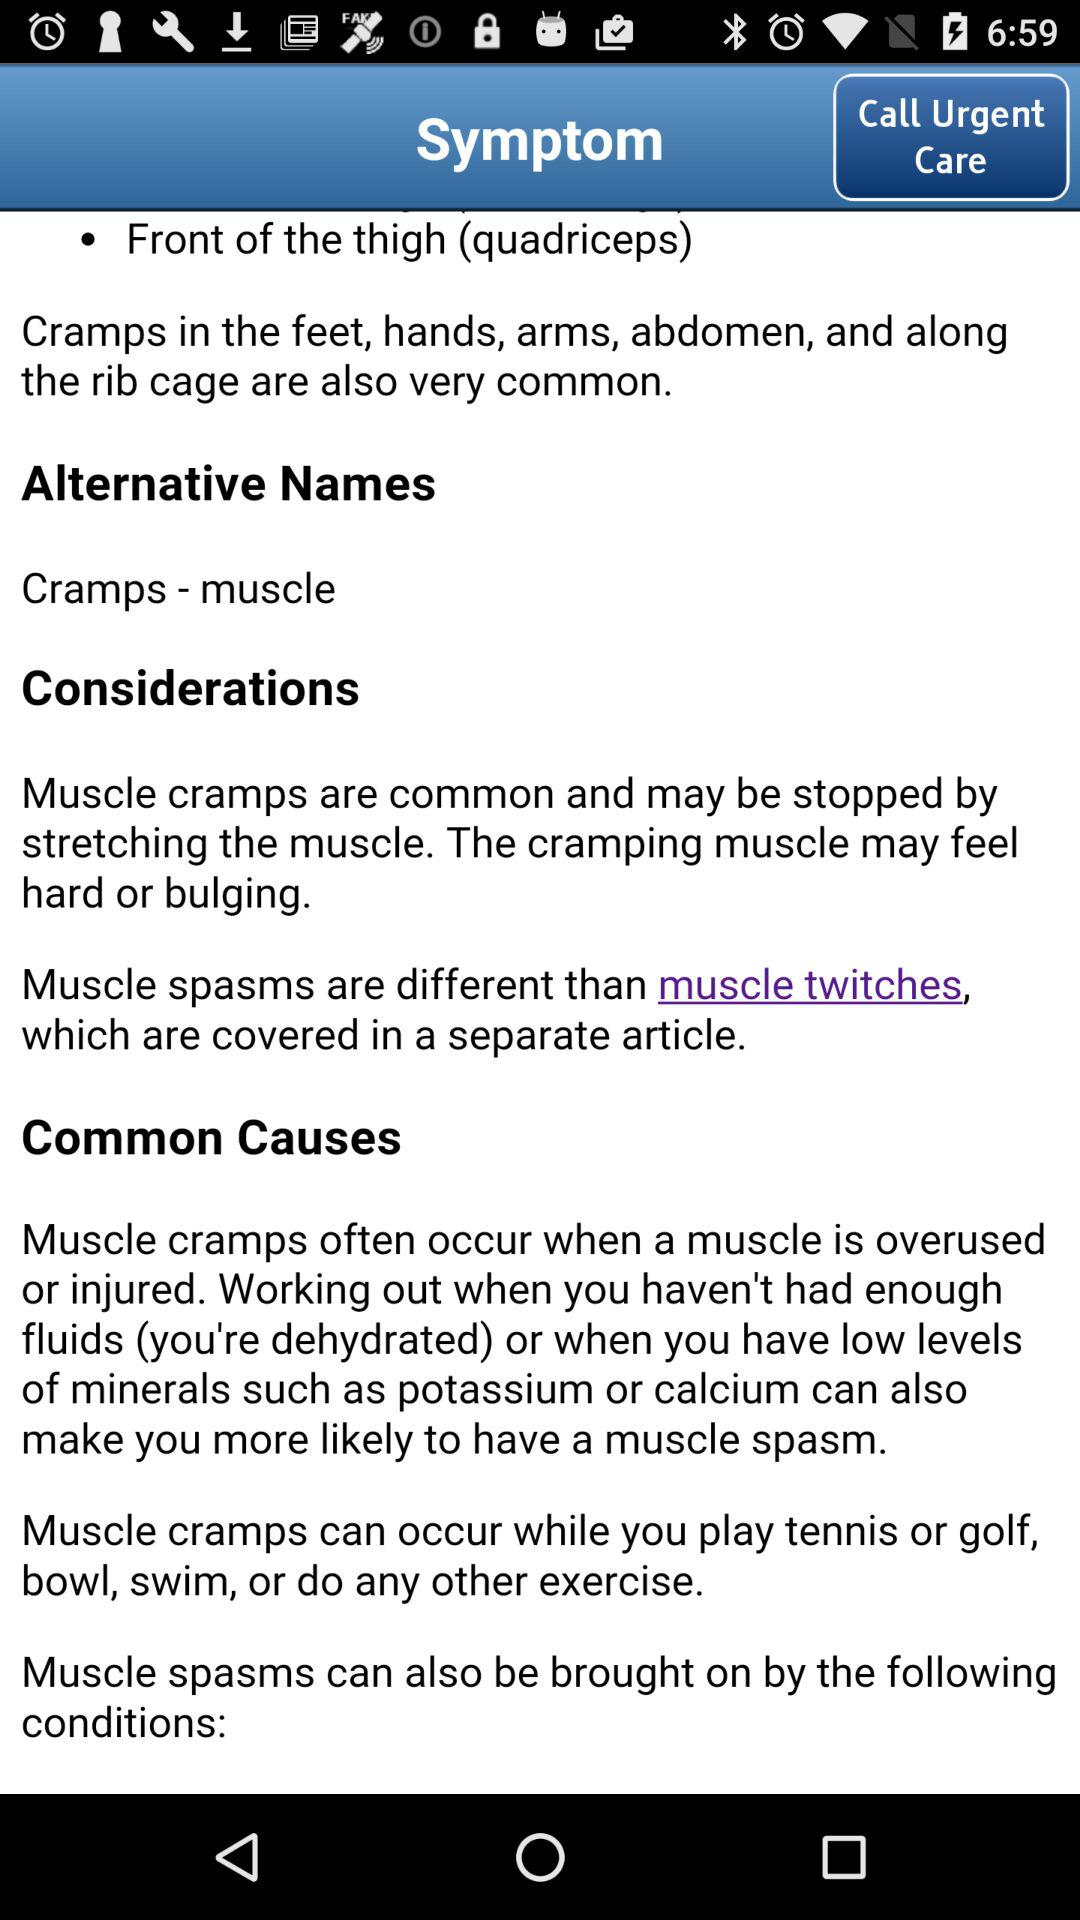By what exercise can muscle cramps be stopped? Muscle cramps can be stopped by stretching the muscles. 